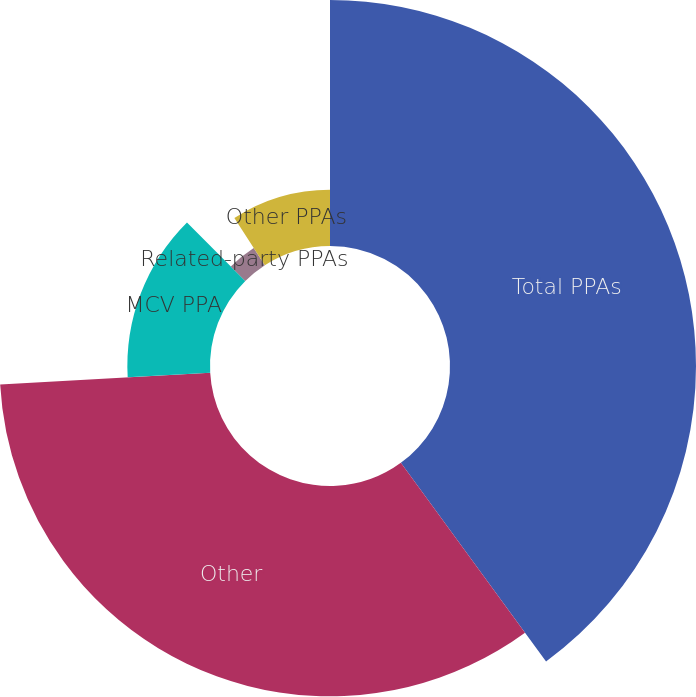<chart> <loc_0><loc_0><loc_500><loc_500><pie_chart><fcel>Total PPAs<fcel>Other<fcel>MCV PPA<fcel>Related-party PPAs<fcel>Other PPAs<nl><fcel>39.95%<fcel>34.16%<fcel>13.42%<fcel>3.34%<fcel>9.13%<nl></chart> 